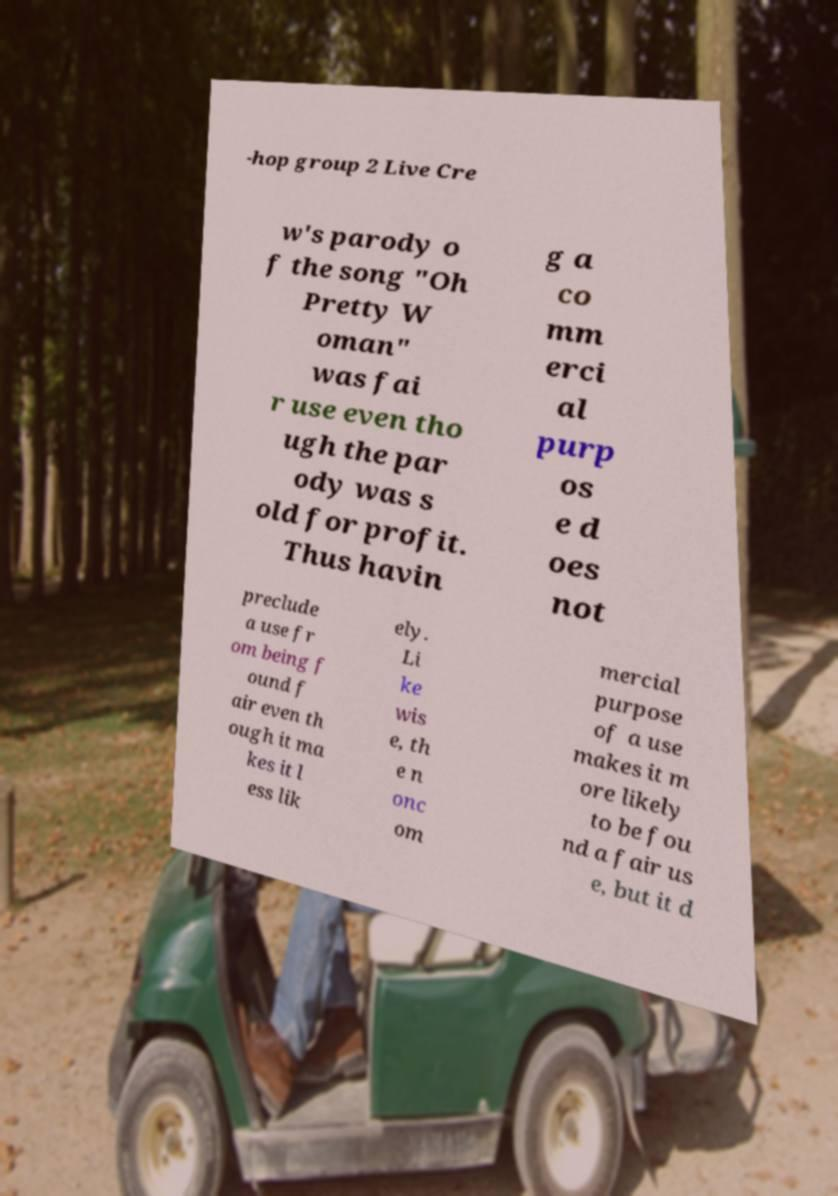Can you read and provide the text displayed in the image?This photo seems to have some interesting text. Can you extract and type it out for me? -hop group 2 Live Cre w's parody o f the song "Oh Pretty W oman" was fai r use even tho ugh the par ody was s old for profit. Thus havin g a co mm erci al purp os e d oes not preclude a use fr om being f ound f air even th ough it ma kes it l ess lik ely. Li ke wis e, th e n onc om mercial purpose of a use makes it m ore likely to be fou nd a fair us e, but it d 